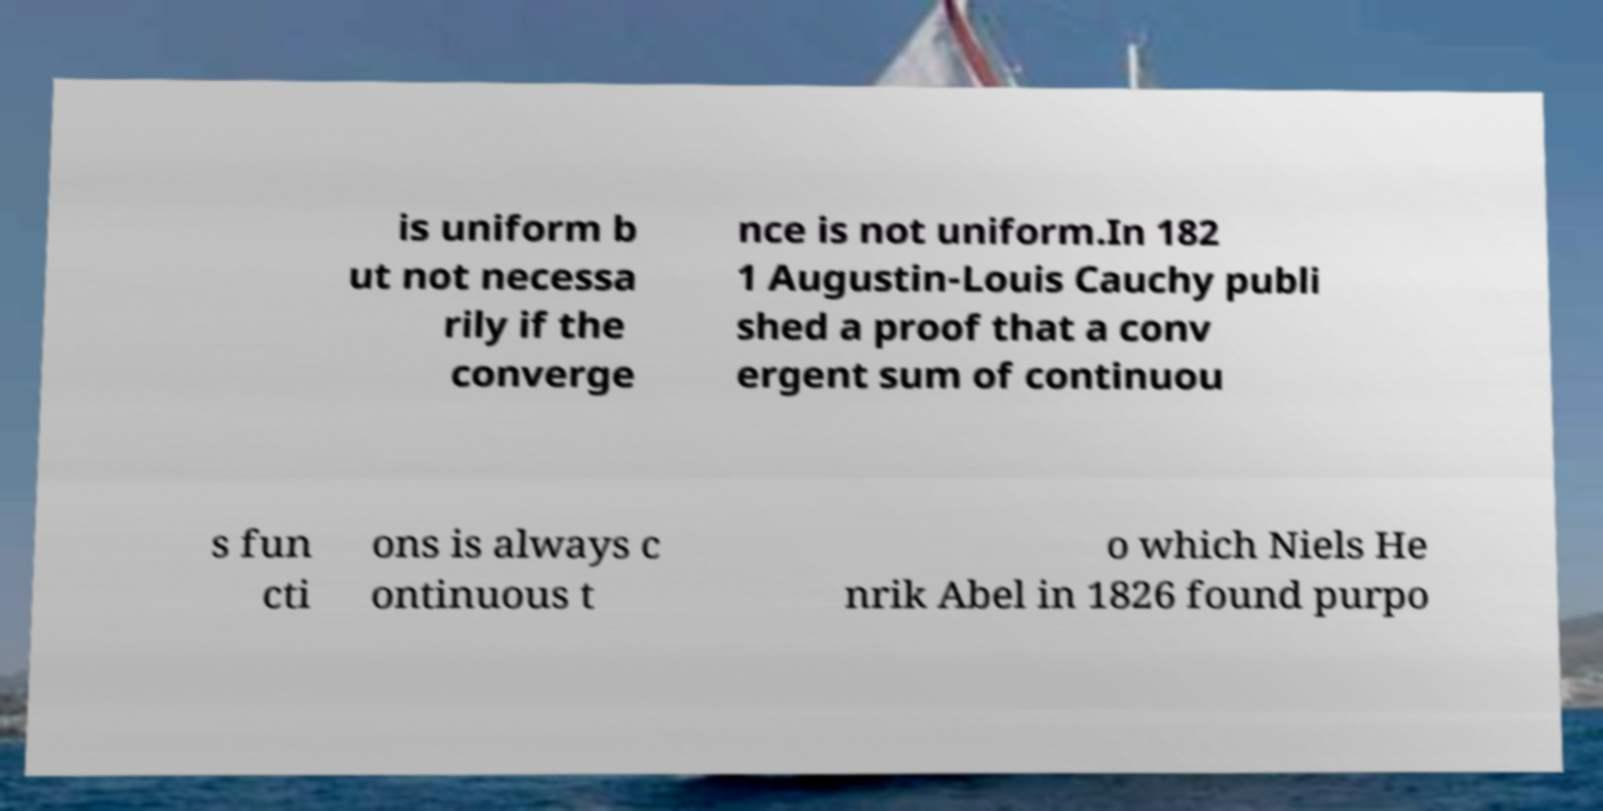Could you extract and type out the text from this image? is uniform b ut not necessa rily if the converge nce is not uniform.In 182 1 Augustin-Louis Cauchy publi shed a proof that a conv ergent sum of continuou s fun cti ons is always c ontinuous t o which Niels He nrik Abel in 1826 found purpo 